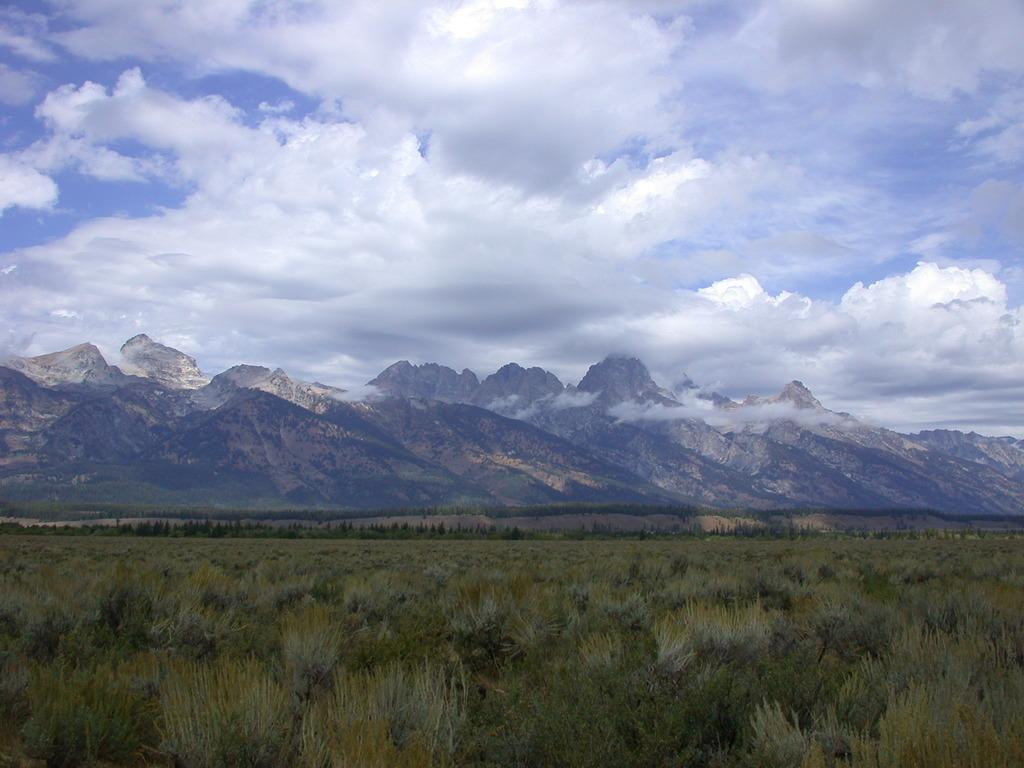What type of vegetation is present in the image? The image contains green grass and plants. What can be seen in the distance in the image? There are mountains in the background of the image. What is visible in the sky in the background of the image? Clouds are visible in the sky in the background of the image. What type of prose can be heard being recited by the bird in the image? There is no bird present in the image, and therefore no prose can be heard. 